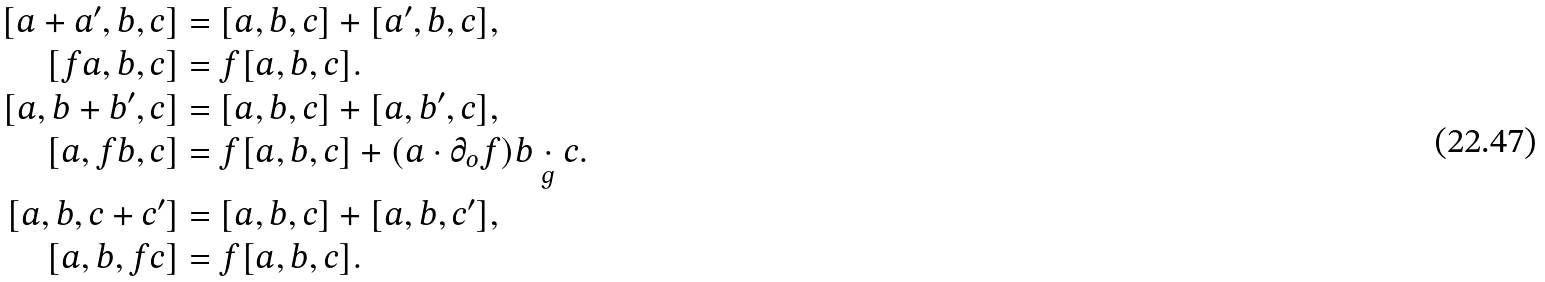<formula> <loc_0><loc_0><loc_500><loc_500>[ a + a ^ { \prime } , b , c ] & = [ a , b , c ] + [ a ^ { \prime } , b , c ] , \\ [ f a , b , c ] & = f [ a , b , c ] . \\ [ a , b + b ^ { \prime } , c ] & = [ a , b , c ] + [ a , b ^ { \prime } , c ] , \\ [ a , f b , c ] & = f [ a , b , c ] + ( a \cdot \partial _ { o } f ) b \underset { g } { \cdot } c . \\ [ a , b , c + c ^ { \prime } ] & = [ a , b , c ] + [ a , b , c ^ { \prime } ] , \\ [ a , b , f c ] & = f [ a , b , c ] .</formula> 